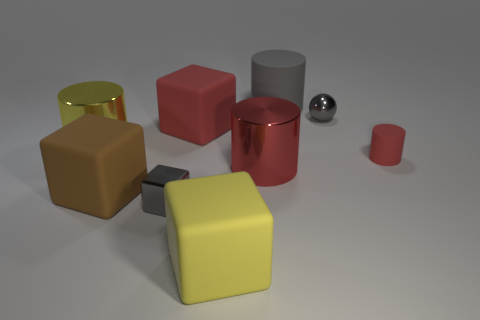There is a rubber thing that is to the right of the tiny shiny thing behind the gray shiny object that is in front of the big yellow cylinder; what is its color?
Provide a succinct answer. Red. What is the material of the red cylinder that is the same size as the brown matte cube?
Your answer should be very brief. Metal. What number of things are matte cubes that are behind the tiny gray cube or yellow cylinders?
Offer a terse response. 3. Is there a big cyan object?
Offer a very short reply. No. What is the tiny gray object that is to the left of the big yellow rubber object made of?
Ensure brevity in your answer.  Metal. There is a large block that is the same color as the small matte thing; what is it made of?
Your response must be concise. Rubber. What number of big things are metal blocks or yellow things?
Your response must be concise. 2. What is the color of the tiny matte cylinder?
Your answer should be very brief. Red. Are there any large matte blocks that are on the left side of the matte cube that is behind the red metallic cylinder?
Provide a short and direct response. Yes. Is the number of gray things that are in front of the large yellow metal object less than the number of cylinders?
Provide a short and direct response. Yes. 